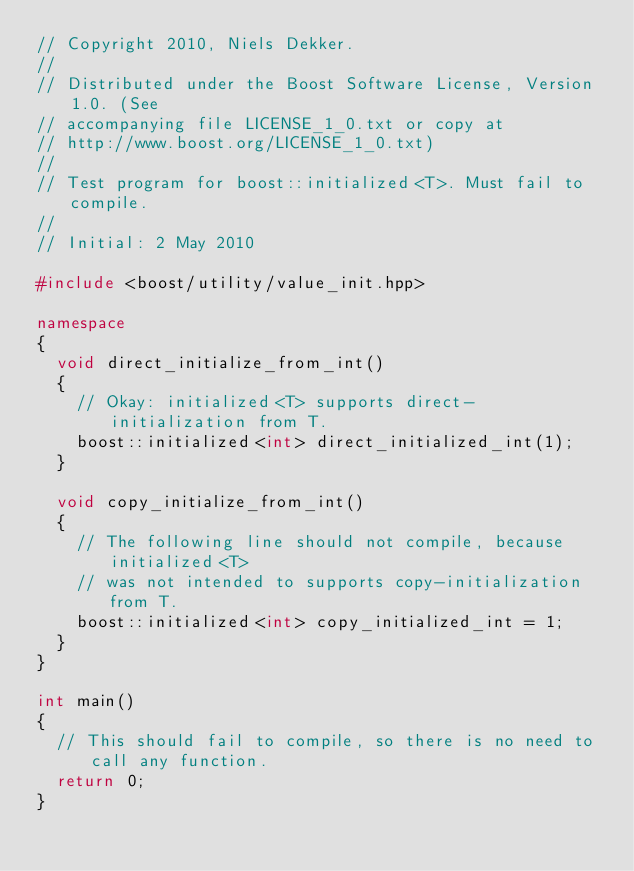<code> <loc_0><loc_0><loc_500><loc_500><_C++_>// Copyright 2010, Niels Dekker.
//
// Distributed under the Boost Software License, Version 1.0. (See
// accompanying file LICENSE_1_0.txt or copy at
// http://www.boost.org/LICENSE_1_0.txt)
//
// Test program for boost::initialized<T>. Must fail to compile.
//
// Initial: 2 May 2010

#include <boost/utility/value_init.hpp>

namespace
{
  void direct_initialize_from_int()
  {
    // Okay: initialized<T> supports direct-initialization from T.
    boost::initialized<int> direct_initialized_int(1);
  }

  void copy_initialize_from_int()
  {
    // The following line should not compile, because initialized<T> 
    // was not intended to supports copy-initialization from T.
    boost::initialized<int> copy_initialized_int = 1;
  }
}

int main()
{
  // This should fail to compile, so there is no need to call any function.
  return 0;
}
</code> 